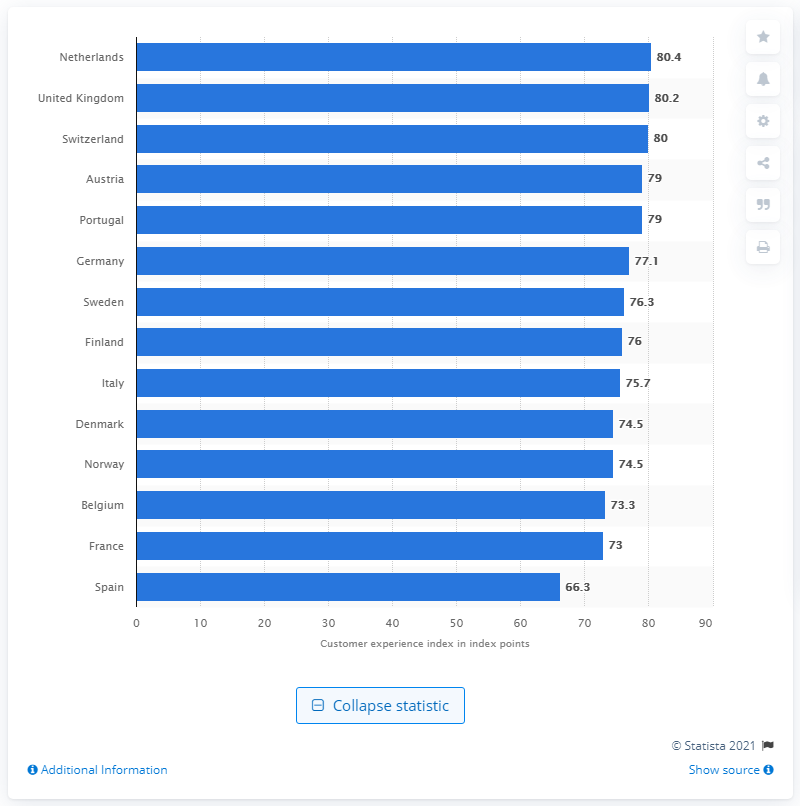Give some essential details in this illustration. As of 2016, the level of the customer experience index for the Netherlands was 80.4. 